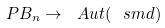Convert formula to latex. <formula><loc_0><loc_0><loc_500><loc_500>P B _ { n } \to \ A u t ( \ s m d )</formula> 